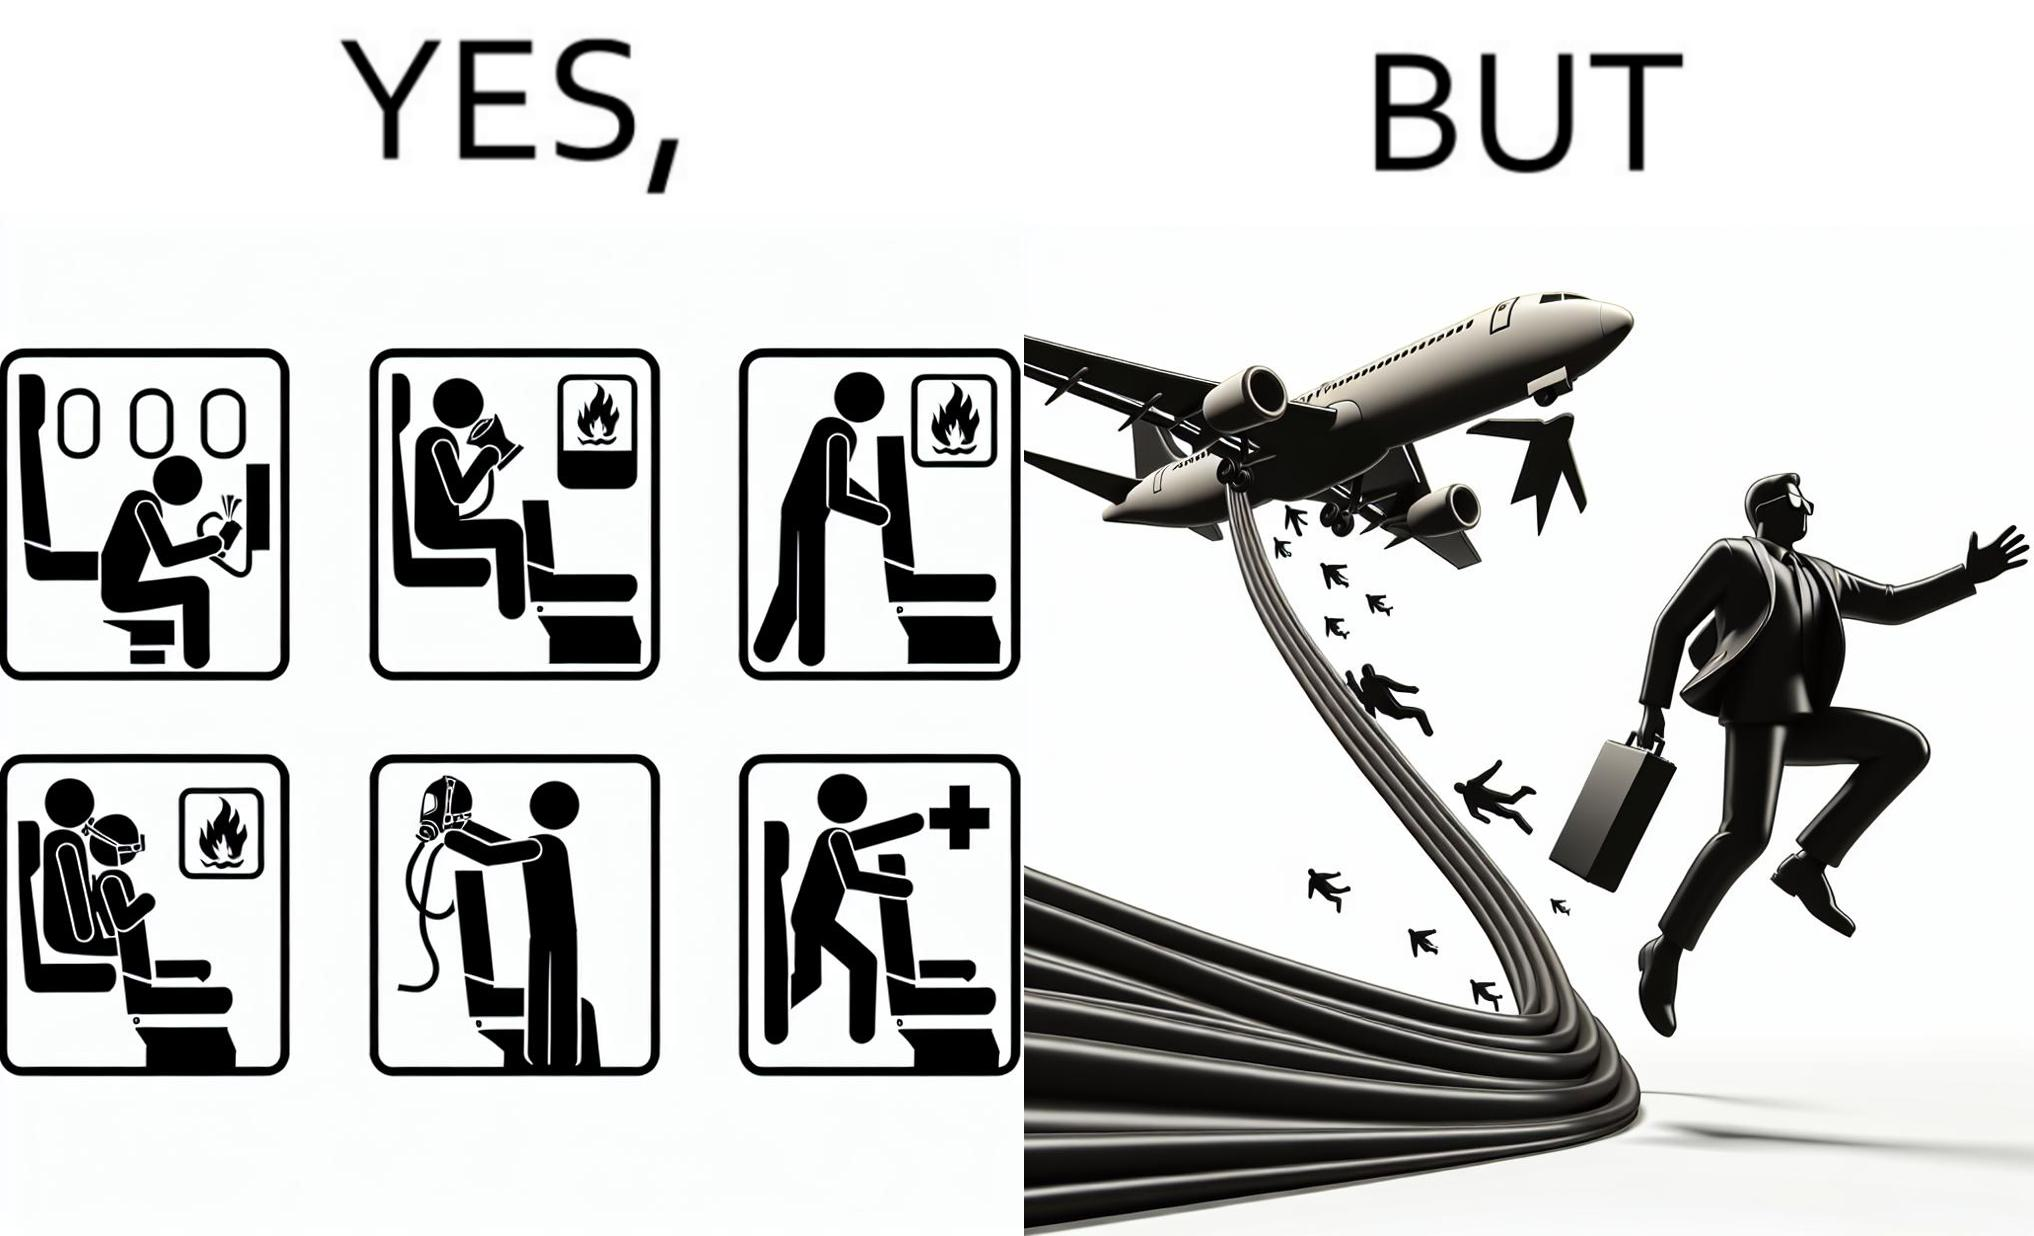What does this image depict? These images are funny since it shows how we are taught emergency procedures to follow in case of an accident while in an airplane but how none of them work if the plane is still in air 